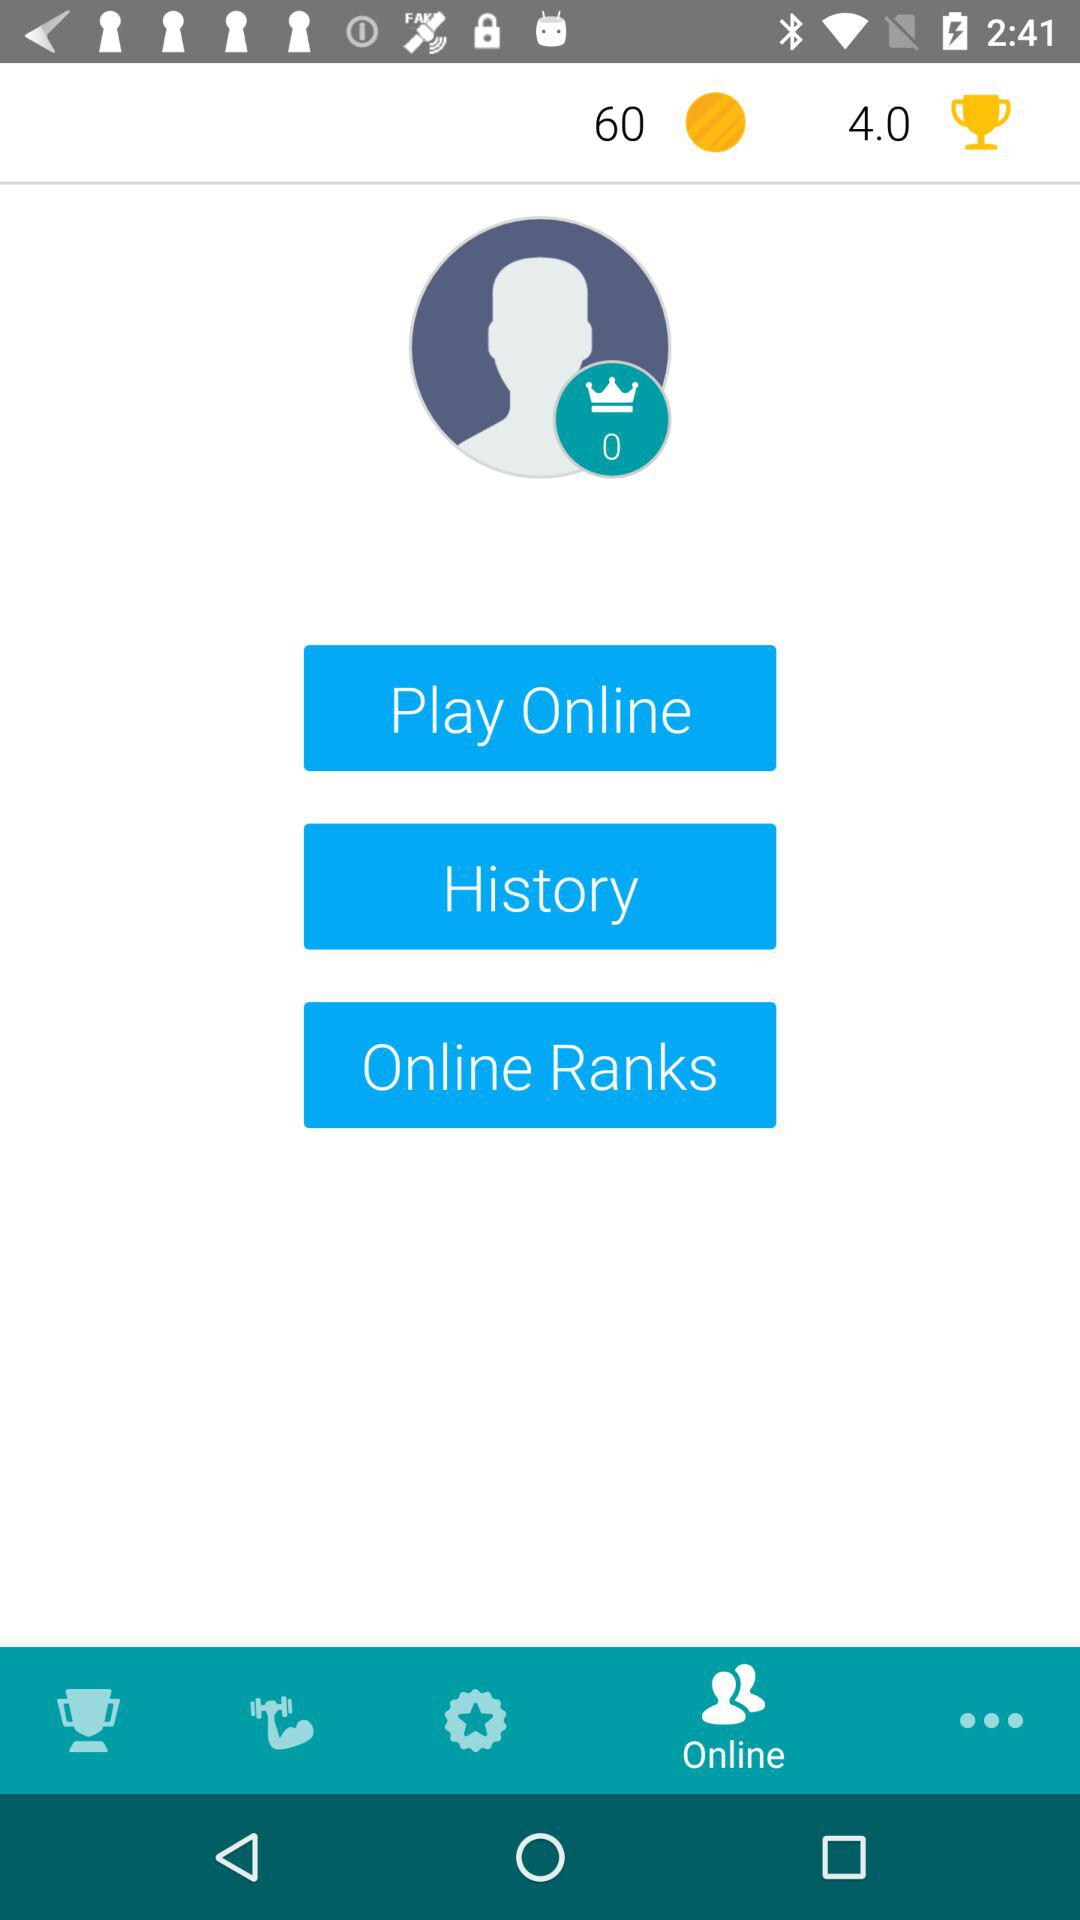What is the count of the crown? The count is 0. 